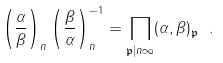<formula> <loc_0><loc_0><loc_500><loc_500>\left ( { \frac { \alpha } { \beta } } \right ) _ { n } \left ( { \frac { \beta } { \alpha } } \right ) _ { n } ^ { - 1 } = \prod _ { { \mathfrak { p } } | n \infty } ( \alpha , \beta ) _ { \mathfrak { p } } \ .</formula> 